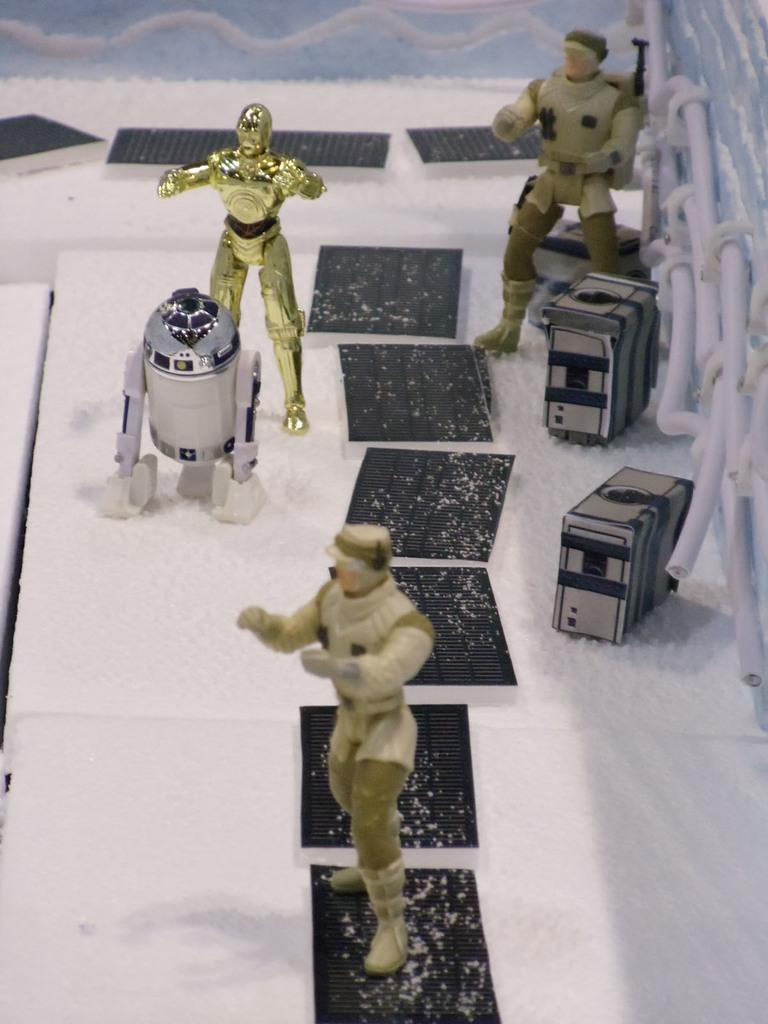What type of items can be seen in the image? There are toys in the image. Are there any other specific items visible in the image? Yes, there are cables in the image. Can you describe any other objects present in the image? There are other objects in the image, but their specific nature is not mentioned in the provided facts. What type of competition is taking place in the image? There is no competition present in the image; it features toys and cables. Can you describe the feather in the image? There is no feather present in the image. 